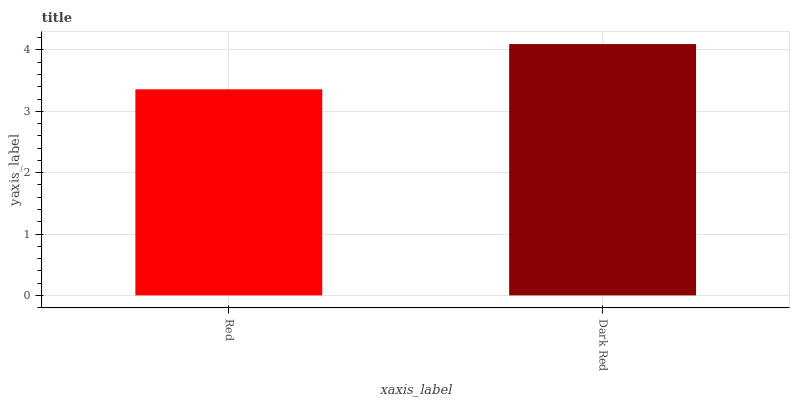Is Red the minimum?
Answer yes or no. Yes. Is Dark Red the maximum?
Answer yes or no. Yes. Is Dark Red the minimum?
Answer yes or no. No. Is Dark Red greater than Red?
Answer yes or no. Yes. Is Red less than Dark Red?
Answer yes or no. Yes. Is Red greater than Dark Red?
Answer yes or no. No. Is Dark Red less than Red?
Answer yes or no. No. Is Dark Red the high median?
Answer yes or no. Yes. Is Red the low median?
Answer yes or no. Yes. Is Red the high median?
Answer yes or no. No. Is Dark Red the low median?
Answer yes or no. No. 